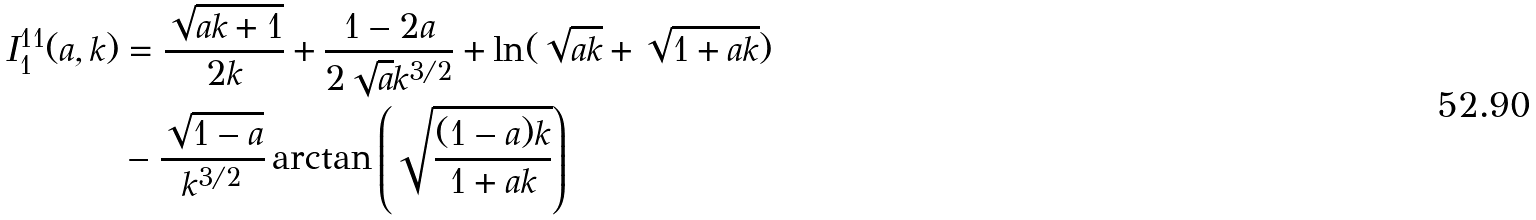Convert formula to latex. <formula><loc_0><loc_0><loc_500><loc_500>I _ { 1 } ^ { 1 1 } ( a , k ) & = \frac { \sqrt { a k + 1 } } { 2 k } + \frac { 1 - 2 a } { 2 \sqrt { a } k ^ { 3 / 2 } } + \ln ( \sqrt { a k } + \sqrt { 1 + a k } ) \\ & - \frac { \sqrt { 1 - a } } { k ^ { 3 / 2 } } \arctan \left ( \sqrt { \frac { ( 1 - a ) k } { 1 + a k } } \right )</formula> 